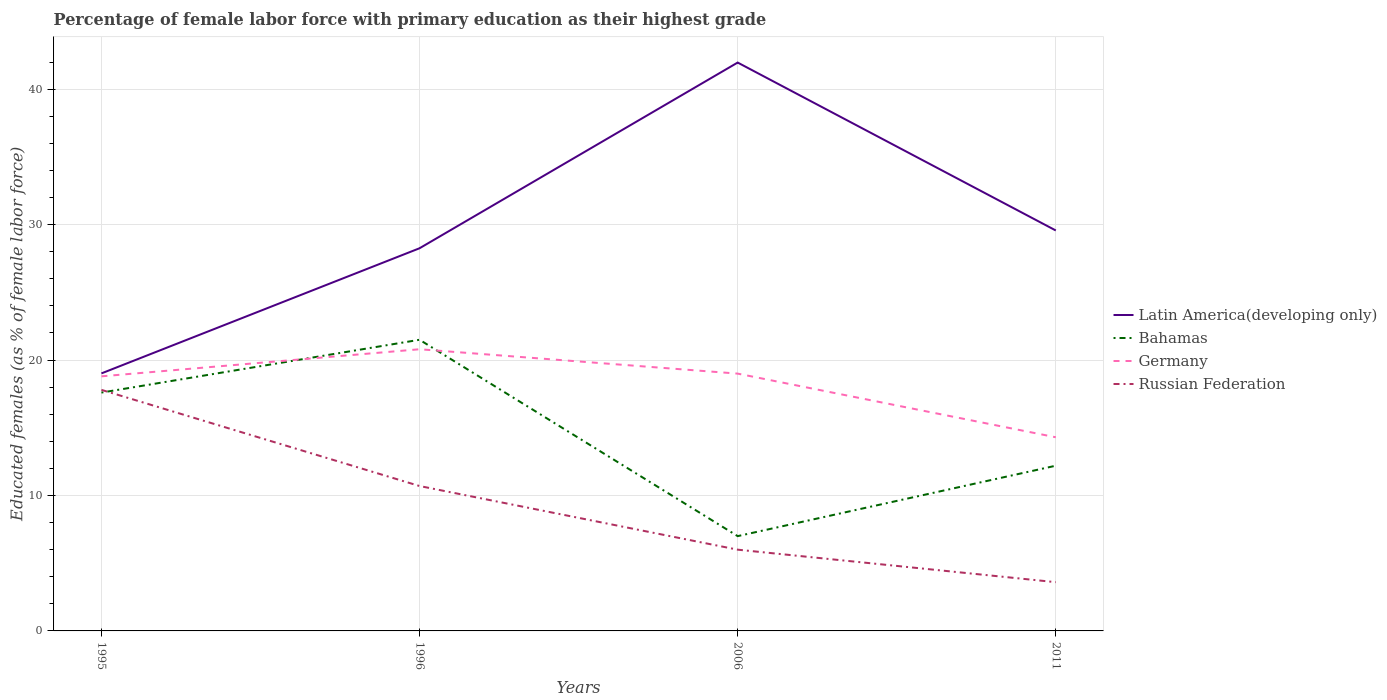How many different coloured lines are there?
Ensure brevity in your answer.  4. Is the number of lines equal to the number of legend labels?
Keep it short and to the point. Yes. Across all years, what is the maximum percentage of female labor force with primary education in Bahamas?
Your answer should be compact. 7. In which year was the percentage of female labor force with primary education in Germany maximum?
Give a very brief answer. 2011. What is the total percentage of female labor force with primary education in Russian Federation in the graph?
Provide a short and direct response. 14.2. What is the difference between the highest and the second highest percentage of female labor force with primary education in Russian Federation?
Offer a very short reply. 14.2. Is the percentage of female labor force with primary education in Latin America(developing only) strictly greater than the percentage of female labor force with primary education in Russian Federation over the years?
Offer a terse response. No. Are the values on the major ticks of Y-axis written in scientific E-notation?
Keep it short and to the point. No. Does the graph contain grids?
Offer a very short reply. Yes. What is the title of the graph?
Your response must be concise. Percentage of female labor force with primary education as their highest grade. Does "Greece" appear as one of the legend labels in the graph?
Your answer should be compact. No. What is the label or title of the Y-axis?
Provide a short and direct response. Educated females (as % of female labor force). What is the Educated females (as % of female labor force) in Latin America(developing only) in 1995?
Your answer should be very brief. 19.02. What is the Educated females (as % of female labor force) of Bahamas in 1995?
Ensure brevity in your answer.  17.6. What is the Educated females (as % of female labor force) of Germany in 1995?
Provide a short and direct response. 18.8. What is the Educated females (as % of female labor force) of Russian Federation in 1995?
Make the answer very short. 17.8. What is the Educated females (as % of female labor force) of Latin America(developing only) in 1996?
Ensure brevity in your answer.  28.26. What is the Educated females (as % of female labor force) in Bahamas in 1996?
Your answer should be very brief. 21.5. What is the Educated females (as % of female labor force) in Germany in 1996?
Keep it short and to the point. 20.8. What is the Educated females (as % of female labor force) in Russian Federation in 1996?
Give a very brief answer. 10.7. What is the Educated females (as % of female labor force) in Latin America(developing only) in 2006?
Give a very brief answer. 41.97. What is the Educated females (as % of female labor force) in Bahamas in 2006?
Give a very brief answer. 7. What is the Educated females (as % of female labor force) of Germany in 2006?
Ensure brevity in your answer.  19. What is the Educated females (as % of female labor force) of Latin America(developing only) in 2011?
Ensure brevity in your answer.  29.57. What is the Educated females (as % of female labor force) of Bahamas in 2011?
Your response must be concise. 12.2. What is the Educated females (as % of female labor force) in Germany in 2011?
Ensure brevity in your answer.  14.3. What is the Educated females (as % of female labor force) of Russian Federation in 2011?
Provide a short and direct response. 3.6. Across all years, what is the maximum Educated females (as % of female labor force) in Latin America(developing only)?
Make the answer very short. 41.97. Across all years, what is the maximum Educated females (as % of female labor force) of Bahamas?
Offer a terse response. 21.5. Across all years, what is the maximum Educated females (as % of female labor force) of Germany?
Your answer should be very brief. 20.8. Across all years, what is the maximum Educated females (as % of female labor force) in Russian Federation?
Keep it short and to the point. 17.8. Across all years, what is the minimum Educated females (as % of female labor force) of Latin America(developing only)?
Your answer should be very brief. 19.02. Across all years, what is the minimum Educated females (as % of female labor force) in Bahamas?
Your answer should be very brief. 7. Across all years, what is the minimum Educated females (as % of female labor force) in Germany?
Your answer should be very brief. 14.3. Across all years, what is the minimum Educated females (as % of female labor force) in Russian Federation?
Provide a short and direct response. 3.6. What is the total Educated females (as % of female labor force) of Latin America(developing only) in the graph?
Keep it short and to the point. 118.81. What is the total Educated females (as % of female labor force) in Bahamas in the graph?
Keep it short and to the point. 58.3. What is the total Educated females (as % of female labor force) in Germany in the graph?
Ensure brevity in your answer.  72.9. What is the total Educated females (as % of female labor force) of Russian Federation in the graph?
Your answer should be compact. 38.1. What is the difference between the Educated females (as % of female labor force) in Latin America(developing only) in 1995 and that in 1996?
Provide a short and direct response. -9.24. What is the difference between the Educated females (as % of female labor force) of Germany in 1995 and that in 1996?
Your response must be concise. -2. What is the difference between the Educated females (as % of female labor force) in Latin America(developing only) in 1995 and that in 2006?
Offer a very short reply. -22.95. What is the difference between the Educated females (as % of female labor force) in Bahamas in 1995 and that in 2006?
Keep it short and to the point. 10.6. What is the difference between the Educated females (as % of female labor force) of Russian Federation in 1995 and that in 2006?
Offer a very short reply. 11.8. What is the difference between the Educated females (as % of female labor force) of Latin America(developing only) in 1995 and that in 2011?
Ensure brevity in your answer.  -10.55. What is the difference between the Educated females (as % of female labor force) of Germany in 1995 and that in 2011?
Provide a short and direct response. 4.5. What is the difference between the Educated females (as % of female labor force) in Latin America(developing only) in 1996 and that in 2006?
Offer a very short reply. -13.71. What is the difference between the Educated females (as % of female labor force) of Germany in 1996 and that in 2006?
Provide a succinct answer. 1.8. What is the difference between the Educated females (as % of female labor force) in Latin America(developing only) in 1996 and that in 2011?
Make the answer very short. -1.31. What is the difference between the Educated females (as % of female labor force) of Bahamas in 1996 and that in 2011?
Your answer should be very brief. 9.3. What is the difference between the Educated females (as % of female labor force) in Latin America(developing only) in 2006 and that in 2011?
Give a very brief answer. 12.4. What is the difference between the Educated females (as % of female labor force) in Latin America(developing only) in 1995 and the Educated females (as % of female labor force) in Bahamas in 1996?
Keep it short and to the point. -2.48. What is the difference between the Educated females (as % of female labor force) in Latin America(developing only) in 1995 and the Educated females (as % of female labor force) in Germany in 1996?
Keep it short and to the point. -1.78. What is the difference between the Educated females (as % of female labor force) in Latin America(developing only) in 1995 and the Educated females (as % of female labor force) in Russian Federation in 1996?
Ensure brevity in your answer.  8.32. What is the difference between the Educated females (as % of female labor force) in Bahamas in 1995 and the Educated females (as % of female labor force) in Germany in 1996?
Your answer should be compact. -3.2. What is the difference between the Educated females (as % of female labor force) of Latin America(developing only) in 1995 and the Educated females (as % of female labor force) of Bahamas in 2006?
Your answer should be very brief. 12.02. What is the difference between the Educated females (as % of female labor force) of Latin America(developing only) in 1995 and the Educated females (as % of female labor force) of Germany in 2006?
Offer a terse response. 0.02. What is the difference between the Educated females (as % of female labor force) of Latin America(developing only) in 1995 and the Educated females (as % of female labor force) of Russian Federation in 2006?
Your response must be concise. 13.02. What is the difference between the Educated females (as % of female labor force) in Bahamas in 1995 and the Educated females (as % of female labor force) in Germany in 2006?
Offer a very short reply. -1.4. What is the difference between the Educated females (as % of female labor force) in Bahamas in 1995 and the Educated females (as % of female labor force) in Russian Federation in 2006?
Your answer should be compact. 11.6. What is the difference between the Educated females (as % of female labor force) of Germany in 1995 and the Educated females (as % of female labor force) of Russian Federation in 2006?
Make the answer very short. 12.8. What is the difference between the Educated females (as % of female labor force) of Latin America(developing only) in 1995 and the Educated females (as % of female labor force) of Bahamas in 2011?
Your answer should be compact. 6.82. What is the difference between the Educated females (as % of female labor force) of Latin America(developing only) in 1995 and the Educated females (as % of female labor force) of Germany in 2011?
Your answer should be very brief. 4.72. What is the difference between the Educated females (as % of female labor force) of Latin America(developing only) in 1995 and the Educated females (as % of female labor force) of Russian Federation in 2011?
Make the answer very short. 15.42. What is the difference between the Educated females (as % of female labor force) in Bahamas in 1995 and the Educated females (as % of female labor force) in Russian Federation in 2011?
Offer a very short reply. 14. What is the difference between the Educated females (as % of female labor force) in Latin America(developing only) in 1996 and the Educated females (as % of female labor force) in Bahamas in 2006?
Your answer should be compact. 21.26. What is the difference between the Educated females (as % of female labor force) in Latin America(developing only) in 1996 and the Educated females (as % of female labor force) in Germany in 2006?
Ensure brevity in your answer.  9.26. What is the difference between the Educated females (as % of female labor force) in Latin America(developing only) in 1996 and the Educated females (as % of female labor force) in Russian Federation in 2006?
Your answer should be very brief. 22.26. What is the difference between the Educated females (as % of female labor force) of Bahamas in 1996 and the Educated females (as % of female labor force) of Germany in 2006?
Provide a short and direct response. 2.5. What is the difference between the Educated females (as % of female labor force) of Latin America(developing only) in 1996 and the Educated females (as % of female labor force) of Bahamas in 2011?
Keep it short and to the point. 16.06. What is the difference between the Educated females (as % of female labor force) in Latin America(developing only) in 1996 and the Educated females (as % of female labor force) in Germany in 2011?
Ensure brevity in your answer.  13.96. What is the difference between the Educated females (as % of female labor force) in Latin America(developing only) in 1996 and the Educated females (as % of female labor force) in Russian Federation in 2011?
Keep it short and to the point. 24.66. What is the difference between the Educated females (as % of female labor force) of Bahamas in 1996 and the Educated females (as % of female labor force) of Germany in 2011?
Give a very brief answer. 7.2. What is the difference between the Educated females (as % of female labor force) of Latin America(developing only) in 2006 and the Educated females (as % of female labor force) of Bahamas in 2011?
Ensure brevity in your answer.  29.77. What is the difference between the Educated females (as % of female labor force) of Latin America(developing only) in 2006 and the Educated females (as % of female labor force) of Germany in 2011?
Offer a terse response. 27.67. What is the difference between the Educated females (as % of female labor force) of Latin America(developing only) in 2006 and the Educated females (as % of female labor force) of Russian Federation in 2011?
Keep it short and to the point. 38.37. What is the difference between the Educated females (as % of female labor force) of Bahamas in 2006 and the Educated females (as % of female labor force) of Germany in 2011?
Offer a terse response. -7.3. What is the difference between the Educated females (as % of female labor force) in Bahamas in 2006 and the Educated females (as % of female labor force) in Russian Federation in 2011?
Offer a very short reply. 3.4. What is the average Educated females (as % of female labor force) of Latin America(developing only) per year?
Offer a very short reply. 29.7. What is the average Educated females (as % of female labor force) of Bahamas per year?
Offer a terse response. 14.57. What is the average Educated females (as % of female labor force) in Germany per year?
Your answer should be very brief. 18.23. What is the average Educated females (as % of female labor force) of Russian Federation per year?
Give a very brief answer. 9.53. In the year 1995, what is the difference between the Educated females (as % of female labor force) in Latin America(developing only) and Educated females (as % of female labor force) in Bahamas?
Offer a very short reply. 1.42. In the year 1995, what is the difference between the Educated females (as % of female labor force) of Latin America(developing only) and Educated females (as % of female labor force) of Germany?
Your answer should be very brief. 0.22. In the year 1995, what is the difference between the Educated females (as % of female labor force) of Latin America(developing only) and Educated females (as % of female labor force) of Russian Federation?
Offer a very short reply. 1.22. In the year 1995, what is the difference between the Educated females (as % of female labor force) of Bahamas and Educated females (as % of female labor force) of Russian Federation?
Give a very brief answer. -0.2. In the year 1996, what is the difference between the Educated females (as % of female labor force) of Latin America(developing only) and Educated females (as % of female labor force) of Bahamas?
Give a very brief answer. 6.76. In the year 1996, what is the difference between the Educated females (as % of female labor force) in Latin America(developing only) and Educated females (as % of female labor force) in Germany?
Provide a short and direct response. 7.46. In the year 1996, what is the difference between the Educated females (as % of female labor force) of Latin America(developing only) and Educated females (as % of female labor force) of Russian Federation?
Offer a terse response. 17.56. In the year 1996, what is the difference between the Educated females (as % of female labor force) in Bahamas and Educated females (as % of female labor force) in Russian Federation?
Offer a very short reply. 10.8. In the year 1996, what is the difference between the Educated females (as % of female labor force) of Germany and Educated females (as % of female labor force) of Russian Federation?
Keep it short and to the point. 10.1. In the year 2006, what is the difference between the Educated females (as % of female labor force) of Latin America(developing only) and Educated females (as % of female labor force) of Bahamas?
Provide a succinct answer. 34.97. In the year 2006, what is the difference between the Educated females (as % of female labor force) of Latin America(developing only) and Educated females (as % of female labor force) of Germany?
Make the answer very short. 22.97. In the year 2006, what is the difference between the Educated females (as % of female labor force) of Latin America(developing only) and Educated females (as % of female labor force) of Russian Federation?
Provide a short and direct response. 35.97. In the year 2006, what is the difference between the Educated females (as % of female labor force) of Bahamas and Educated females (as % of female labor force) of Russian Federation?
Give a very brief answer. 1. In the year 2006, what is the difference between the Educated females (as % of female labor force) in Germany and Educated females (as % of female labor force) in Russian Federation?
Give a very brief answer. 13. In the year 2011, what is the difference between the Educated females (as % of female labor force) in Latin America(developing only) and Educated females (as % of female labor force) in Bahamas?
Provide a short and direct response. 17.37. In the year 2011, what is the difference between the Educated females (as % of female labor force) of Latin America(developing only) and Educated females (as % of female labor force) of Germany?
Your answer should be very brief. 15.27. In the year 2011, what is the difference between the Educated females (as % of female labor force) in Latin America(developing only) and Educated females (as % of female labor force) in Russian Federation?
Make the answer very short. 25.97. In the year 2011, what is the difference between the Educated females (as % of female labor force) in Bahamas and Educated females (as % of female labor force) in Germany?
Give a very brief answer. -2.1. In the year 2011, what is the difference between the Educated females (as % of female labor force) in Bahamas and Educated females (as % of female labor force) in Russian Federation?
Make the answer very short. 8.6. What is the ratio of the Educated females (as % of female labor force) in Latin America(developing only) in 1995 to that in 1996?
Ensure brevity in your answer.  0.67. What is the ratio of the Educated females (as % of female labor force) of Bahamas in 1995 to that in 1996?
Provide a short and direct response. 0.82. What is the ratio of the Educated females (as % of female labor force) in Germany in 1995 to that in 1996?
Ensure brevity in your answer.  0.9. What is the ratio of the Educated females (as % of female labor force) in Russian Federation in 1995 to that in 1996?
Your response must be concise. 1.66. What is the ratio of the Educated females (as % of female labor force) in Latin America(developing only) in 1995 to that in 2006?
Your answer should be very brief. 0.45. What is the ratio of the Educated females (as % of female labor force) in Bahamas in 1995 to that in 2006?
Give a very brief answer. 2.51. What is the ratio of the Educated females (as % of female labor force) of Germany in 1995 to that in 2006?
Offer a terse response. 0.99. What is the ratio of the Educated females (as % of female labor force) in Russian Federation in 1995 to that in 2006?
Ensure brevity in your answer.  2.97. What is the ratio of the Educated females (as % of female labor force) of Latin America(developing only) in 1995 to that in 2011?
Give a very brief answer. 0.64. What is the ratio of the Educated females (as % of female labor force) in Bahamas in 1995 to that in 2011?
Give a very brief answer. 1.44. What is the ratio of the Educated females (as % of female labor force) of Germany in 1995 to that in 2011?
Give a very brief answer. 1.31. What is the ratio of the Educated females (as % of female labor force) of Russian Federation in 1995 to that in 2011?
Your response must be concise. 4.94. What is the ratio of the Educated females (as % of female labor force) in Latin America(developing only) in 1996 to that in 2006?
Give a very brief answer. 0.67. What is the ratio of the Educated females (as % of female labor force) in Bahamas in 1996 to that in 2006?
Provide a succinct answer. 3.07. What is the ratio of the Educated females (as % of female labor force) in Germany in 1996 to that in 2006?
Your answer should be compact. 1.09. What is the ratio of the Educated females (as % of female labor force) in Russian Federation in 1996 to that in 2006?
Keep it short and to the point. 1.78. What is the ratio of the Educated females (as % of female labor force) in Latin America(developing only) in 1996 to that in 2011?
Give a very brief answer. 0.96. What is the ratio of the Educated females (as % of female labor force) in Bahamas in 1996 to that in 2011?
Give a very brief answer. 1.76. What is the ratio of the Educated females (as % of female labor force) of Germany in 1996 to that in 2011?
Ensure brevity in your answer.  1.45. What is the ratio of the Educated females (as % of female labor force) of Russian Federation in 1996 to that in 2011?
Your answer should be compact. 2.97. What is the ratio of the Educated females (as % of female labor force) of Latin America(developing only) in 2006 to that in 2011?
Ensure brevity in your answer.  1.42. What is the ratio of the Educated females (as % of female labor force) of Bahamas in 2006 to that in 2011?
Offer a terse response. 0.57. What is the ratio of the Educated females (as % of female labor force) in Germany in 2006 to that in 2011?
Make the answer very short. 1.33. What is the difference between the highest and the second highest Educated females (as % of female labor force) of Latin America(developing only)?
Make the answer very short. 12.4. What is the difference between the highest and the second highest Educated females (as % of female labor force) of Russian Federation?
Keep it short and to the point. 7.1. What is the difference between the highest and the lowest Educated females (as % of female labor force) in Latin America(developing only)?
Ensure brevity in your answer.  22.95. 